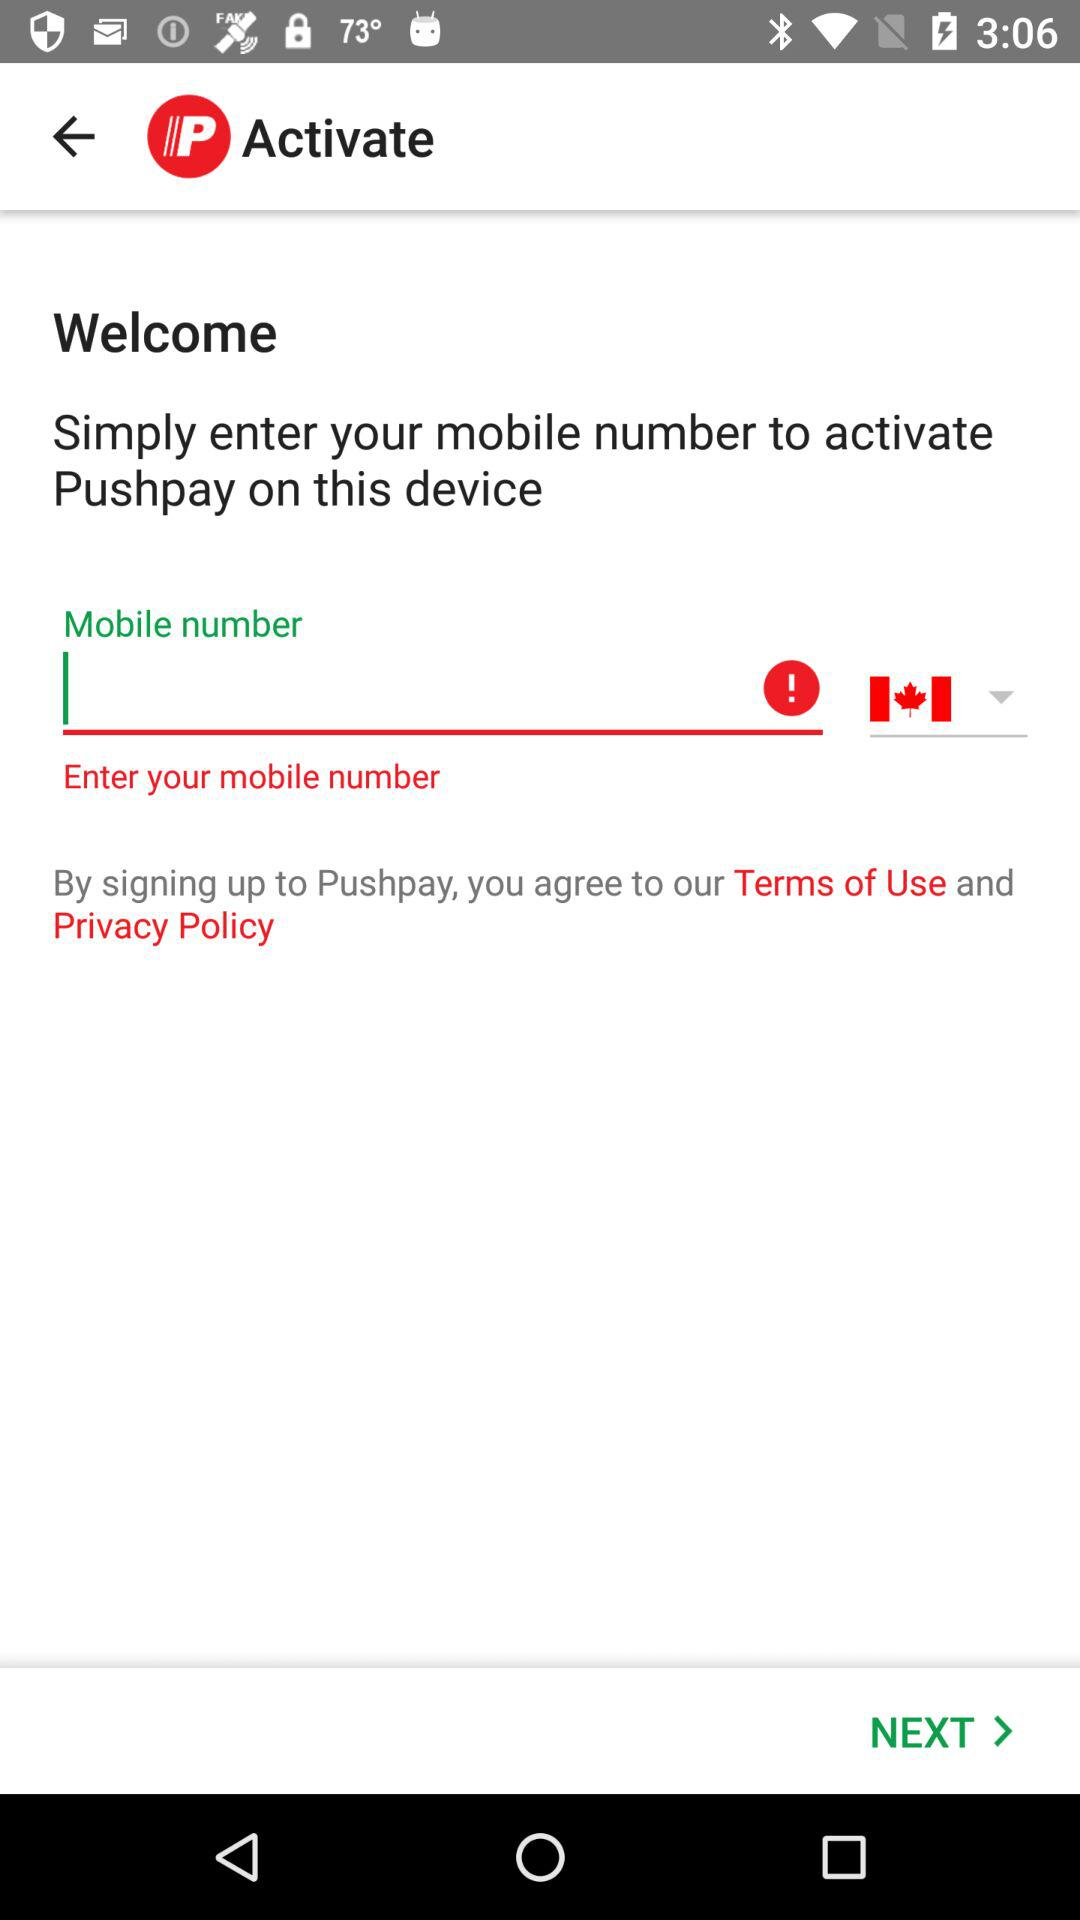How many Canadian flags are on the screen?
Answer the question using a single word or phrase. 1 